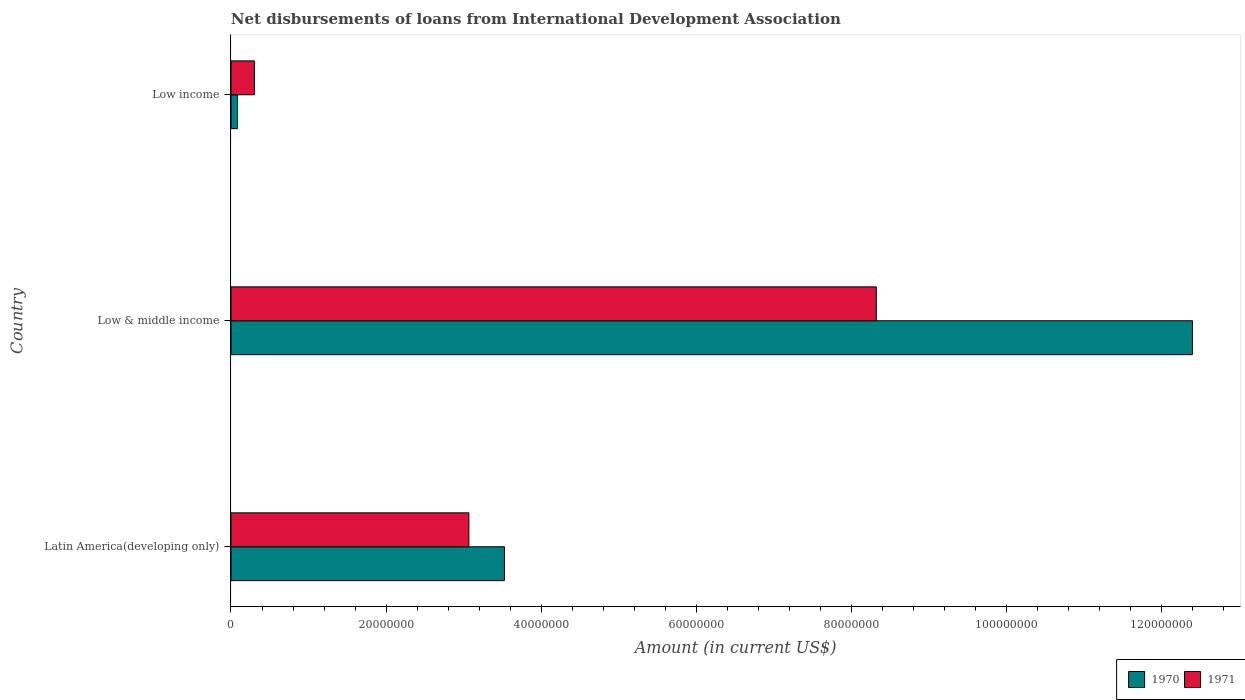How many groups of bars are there?
Your response must be concise. 3. How many bars are there on the 3rd tick from the bottom?
Ensure brevity in your answer.  2. What is the label of the 1st group of bars from the top?
Offer a terse response. Low income. In how many cases, is the number of bars for a given country not equal to the number of legend labels?
Your response must be concise. 0. What is the amount of loans disbursed in 1970 in Low income?
Offer a terse response. 8.35e+05. Across all countries, what is the maximum amount of loans disbursed in 1970?
Keep it short and to the point. 1.24e+08. Across all countries, what is the minimum amount of loans disbursed in 1971?
Provide a succinct answer. 3.02e+06. What is the total amount of loans disbursed in 1970 in the graph?
Keep it short and to the point. 1.60e+08. What is the difference between the amount of loans disbursed in 1971 in Low & middle income and that in Low income?
Provide a succinct answer. 8.02e+07. What is the difference between the amount of loans disbursed in 1971 in Low & middle income and the amount of loans disbursed in 1970 in Latin America(developing only)?
Provide a succinct answer. 4.80e+07. What is the average amount of loans disbursed in 1971 per country?
Your answer should be compact. 3.90e+07. What is the difference between the amount of loans disbursed in 1970 and amount of loans disbursed in 1971 in Low & middle income?
Give a very brief answer. 4.08e+07. In how many countries, is the amount of loans disbursed in 1970 greater than 68000000 US$?
Provide a short and direct response. 1. What is the ratio of the amount of loans disbursed in 1970 in Latin America(developing only) to that in Low & middle income?
Make the answer very short. 0.28. Is the amount of loans disbursed in 1970 in Low & middle income less than that in Low income?
Offer a very short reply. No. What is the difference between the highest and the second highest amount of loans disbursed in 1970?
Ensure brevity in your answer.  8.87e+07. What is the difference between the highest and the lowest amount of loans disbursed in 1971?
Your answer should be compact. 8.02e+07. In how many countries, is the amount of loans disbursed in 1971 greater than the average amount of loans disbursed in 1971 taken over all countries?
Provide a succinct answer. 1. Is the sum of the amount of loans disbursed in 1970 in Low & middle income and Low income greater than the maximum amount of loans disbursed in 1971 across all countries?
Keep it short and to the point. Yes. How many countries are there in the graph?
Your answer should be compact. 3. Are the values on the major ticks of X-axis written in scientific E-notation?
Your response must be concise. No. Does the graph contain any zero values?
Ensure brevity in your answer.  No. Does the graph contain grids?
Ensure brevity in your answer.  No. What is the title of the graph?
Ensure brevity in your answer.  Net disbursements of loans from International Development Association. Does "1976" appear as one of the legend labels in the graph?
Make the answer very short. No. What is the Amount (in current US$) of 1970 in Latin America(developing only)?
Ensure brevity in your answer.  3.53e+07. What is the Amount (in current US$) of 1971 in Latin America(developing only)?
Your answer should be very brief. 3.07e+07. What is the Amount (in current US$) in 1970 in Low & middle income?
Keep it short and to the point. 1.24e+08. What is the Amount (in current US$) of 1971 in Low & middle income?
Give a very brief answer. 8.32e+07. What is the Amount (in current US$) of 1970 in Low income?
Ensure brevity in your answer.  8.35e+05. What is the Amount (in current US$) in 1971 in Low income?
Your response must be concise. 3.02e+06. Across all countries, what is the maximum Amount (in current US$) of 1970?
Your answer should be very brief. 1.24e+08. Across all countries, what is the maximum Amount (in current US$) of 1971?
Keep it short and to the point. 8.32e+07. Across all countries, what is the minimum Amount (in current US$) in 1970?
Provide a succinct answer. 8.35e+05. Across all countries, what is the minimum Amount (in current US$) in 1971?
Offer a terse response. 3.02e+06. What is the total Amount (in current US$) in 1970 in the graph?
Make the answer very short. 1.60e+08. What is the total Amount (in current US$) of 1971 in the graph?
Your response must be concise. 1.17e+08. What is the difference between the Amount (in current US$) of 1970 in Latin America(developing only) and that in Low & middle income?
Offer a terse response. -8.87e+07. What is the difference between the Amount (in current US$) in 1971 in Latin America(developing only) and that in Low & middle income?
Your response must be concise. -5.25e+07. What is the difference between the Amount (in current US$) of 1970 in Latin America(developing only) and that in Low income?
Provide a succinct answer. 3.44e+07. What is the difference between the Amount (in current US$) of 1971 in Latin America(developing only) and that in Low income?
Keep it short and to the point. 2.77e+07. What is the difference between the Amount (in current US$) in 1970 in Low & middle income and that in Low income?
Offer a very short reply. 1.23e+08. What is the difference between the Amount (in current US$) of 1971 in Low & middle income and that in Low income?
Provide a short and direct response. 8.02e+07. What is the difference between the Amount (in current US$) in 1970 in Latin America(developing only) and the Amount (in current US$) in 1971 in Low & middle income?
Keep it short and to the point. -4.80e+07. What is the difference between the Amount (in current US$) of 1970 in Latin America(developing only) and the Amount (in current US$) of 1971 in Low income?
Keep it short and to the point. 3.23e+07. What is the difference between the Amount (in current US$) in 1970 in Low & middle income and the Amount (in current US$) in 1971 in Low income?
Give a very brief answer. 1.21e+08. What is the average Amount (in current US$) in 1970 per country?
Your answer should be very brief. 5.34e+07. What is the average Amount (in current US$) in 1971 per country?
Keep it short and to the point. 3.90e+07. What is the difference between the Amount (in current US$) in 1970 and Amount (in current US$) in 1971 in Latin America(developing only)?
Provide a succinct answer. 4.59e+06. What is the difference between the Amount (in current US$) of 1970 and Amount (in current US$) of 1971 in Low & middle income?
Give a very brief answer. 4.08e+07. What is the difference between the Amount (in current US$) in 1970 and Amount (in current US$) in 1971 in Low income?
Your response must be concise. -2.18e+06. What is the ratio of the Amount (in current US$) of 1970 in Latin America(developing only) to that in Low & middle income?
Give a very brief answer. 0.28. What is the ratio of the Amount (in current US$) in 1971 in Latin America(developing only) to that in Low & middle income?
Ensure brevity in your answer.  0.37. What is the ratio of the Amount (in current US$) in 1970 in Latin America(developing only) to that in Low income?
Your answer should be compact. 42.24. What is the ratio of the Amount (in current US$) of 1971 in Latin America(developing only) to that in Low income?
Ensure brevity in your answer.  10.17. What is the ratio of the Amount (in current US$) in 1970 in Low & middle income to that in Low income?
Your answer should be compact. 148.5. What is the ratio of the Amount (in current US$) of 1971 in Low & middle income to that in Low income?
Provide a succinct answer. 27.59. What is the difference between the highest and the second highest Amount (in current US$) of 1970?
Provide a succinct answer. 8.87e+07. What is the difference between the highest and the second highest Amount (in current US$) in 1971?
Your response must be concise. 5.25e+07. What is the difference between the highest and the lowest Amount (in current US$) in 1970?
Offer a very short reply. 1.23e+08. What is the difference between the highest and the lowest Amount (in current US$) of 1971?
Your response must be concise. 8.02e+07. 